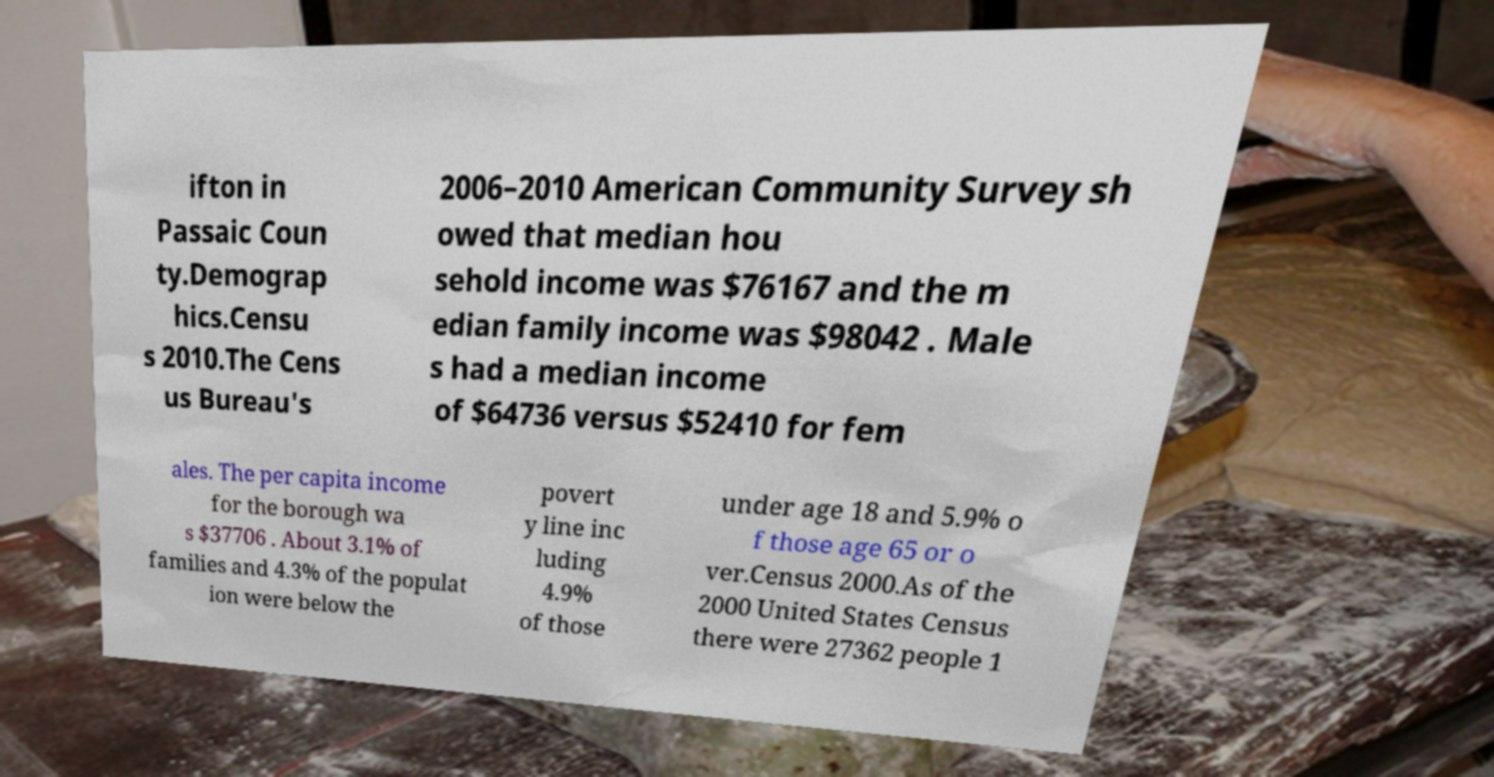Please read and relay the text visible in this image. What does it say? ifton in Passaic Coun ty.Demograp hics.Censu s 2010.The Cens us Bureau's 2006–2010 American Community Survey sh owed that median hou sehold income was $76167 and the m edian family income was $98042 . Male s had a median income of $64736 versus $52410 for fem ales. The per capita income for the borough wa s $37706 . About 3.1% of families and 4.3% of the populat ion were below the povert y line inc luding 4.9% of those under age 18 and 5.9% o f those age 65 or o ver.Census 2000.As of the 2000 United States Census there were 27362 people 1 